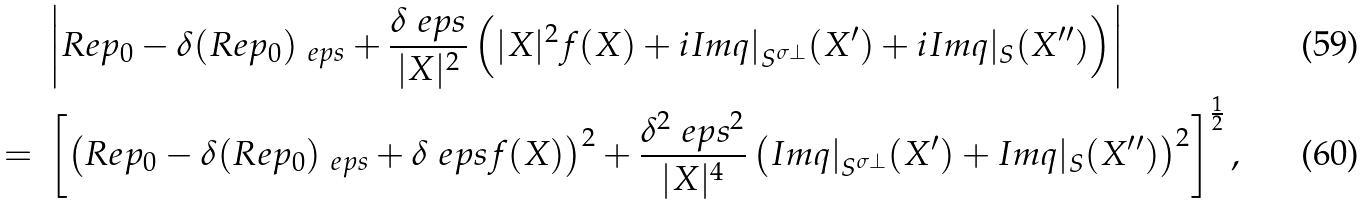<formula> <loc_0><loc_0><loc_500><loc_500>& \ \left | R e p _ { 0 } - \delta ( R e p _ { 0 } ) _ { \ e p s } + \frac { \delta \ e p s } { | X | ^ { 2 } } \left ( | X | ^ { 2 } f ( X ) + i I m q | _ { S ^ { \sigma \perp } } ( X ^ { \prime } ) + i I m q | _ { S } ( X ^ { \prime \prime } ) \right ) \right | \\ = & \ \left [ \left ( R e p _ { 0 } - \delta ( R e p _ { 0 } ) _ { \ e p s } + \delta \ e p s f ( X ) \right ) ^ { 2 } + \frac { \delta ^ { 2 } \ e p s ^ { 2 } } { | X | ^ { 4 } } \left ( I m q | _ { S ^ { \sigma \perp } } ( X ^ { \prime } ) + I m q | _ { S } ( X ^ { \prime \prime } ) \right ) ^ { 2 } \right ] ^ { \frac { 1 } { 2 } } ,</formula> 